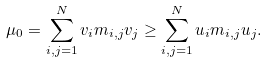<formula> <loc_0><loc_0><loc_500><loc_500>\mu _ { 0 } = \sum _ { i , j = 1 } ^ { N } v _ { i } m _ { i , j } v _ { j } \geq \sum _ { i , j = 1 } ^ { N } u _ { i } m _ { i , j } u _ { j } .</formula> 